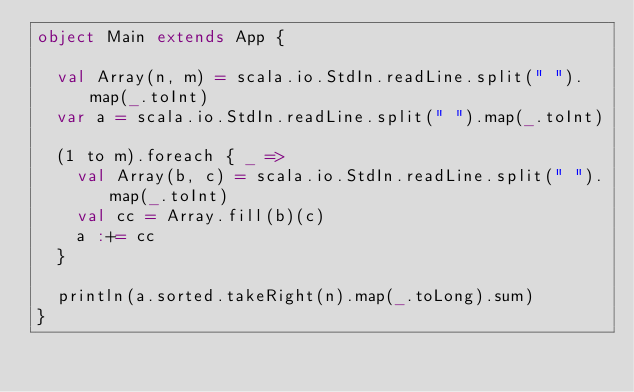Convert code to text. <code><loc_0><loc_0><loc_500><loc_500><_Scala_>object Main extends App {

  val Array(n, m) = scala.io.StdIn.readLine.split(" ").map(_.toInt)
  var a = scala.io.StdIn.readLine.split(" ").map(_.toInt)

  (1 to m).foreach { _ =>
    val Array(b, c) = scala.io.StdIn.readLine.split(" ").map(_.toInt)
    val cc = Array.fill(b)(c)
    a :+= cc
  }

  println(a.sorted.takeRight(n).map(_.toLong).sum)
}</code> 